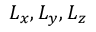Convert formula to latex. <formula><loc_0><loc_0><loc_500><loc_500>L _ { x } , L _ { y } , L _ { z }</formula> 